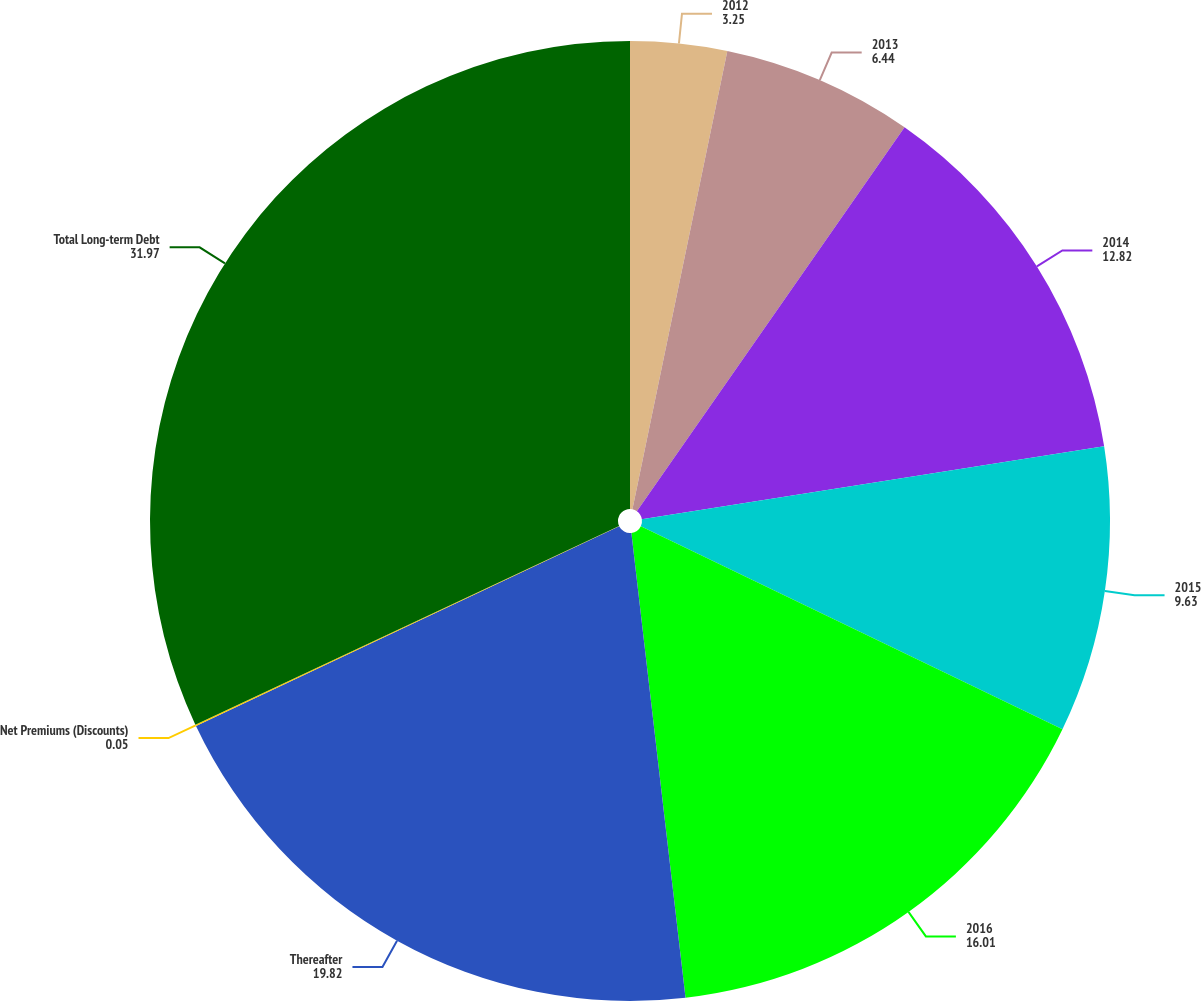Convert chart. <chart><loc_0><loc_0><loc_500><loc_500><pie_chart><fcel>2012<fcel>2013<fcel>2014<fcel>2015<fcel>2016<fcel>Thereafter<fcel>Net Premiums (Discounts)<fcel>Total Long-term Debt<nl><fcel>3.25%<fcel>6.44%<fcel>12.82%<fcel>9.63%<fcel>16.01%<fcel>19.82%<fcel>0.05%<fcel>31.97%<nl></chart> 